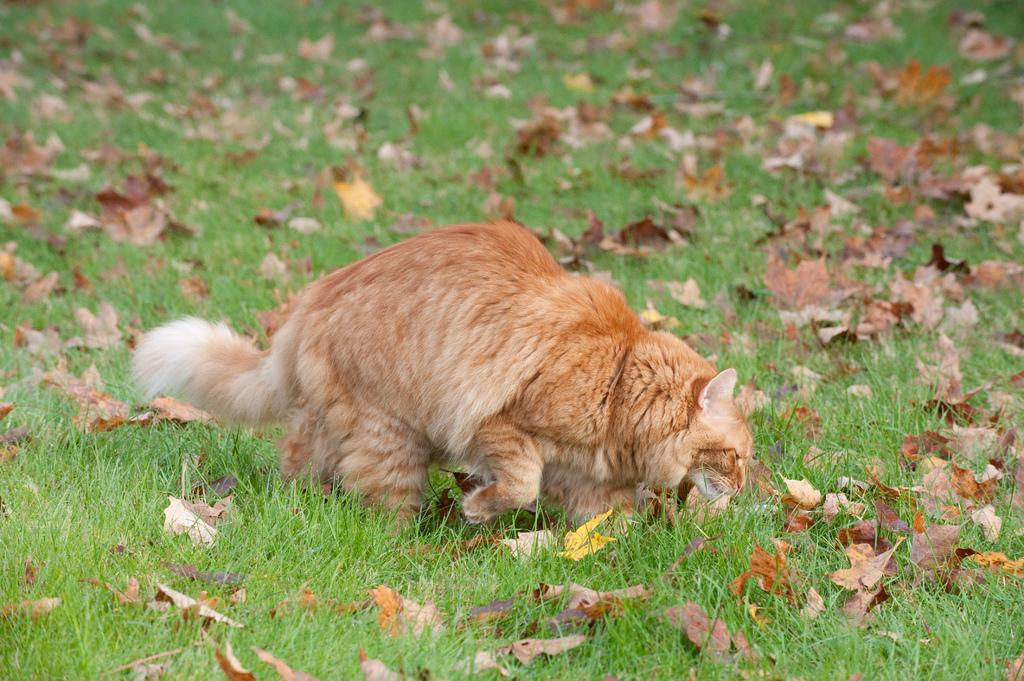What animal can be seen in the image? There is a cat in the image. What is the cat doing in the image? The cat is walking on the grassland. What can be found on the grassland besides the cat? There are dried leaves on the grassland. Can you see the cat smiling in the image? There is no indication of the cat's facial expression in the image, so it cannot be determined if the cat is smiling. 